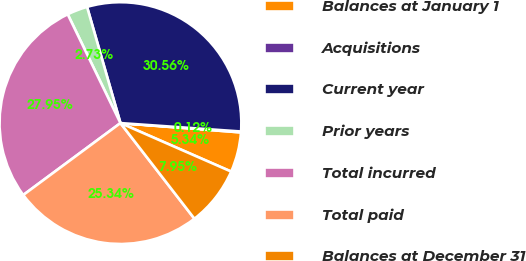<chart> <loc_0><loc_0><loc_500><loc_500><pie_chart><fcel>Balances at January 1<fcel>Acquisitions<fcel>Current year<fcel>Prior years<fcel>Total incurred<fcel>Total paid<fcel>Balances at December 31<nl><fcel>5.34%<fcel>0.12%<fcel>30.56%<fcel>2.73%<fcel>27.95%<fcel>25.34%<fcel>7.95%<nl></chart> 